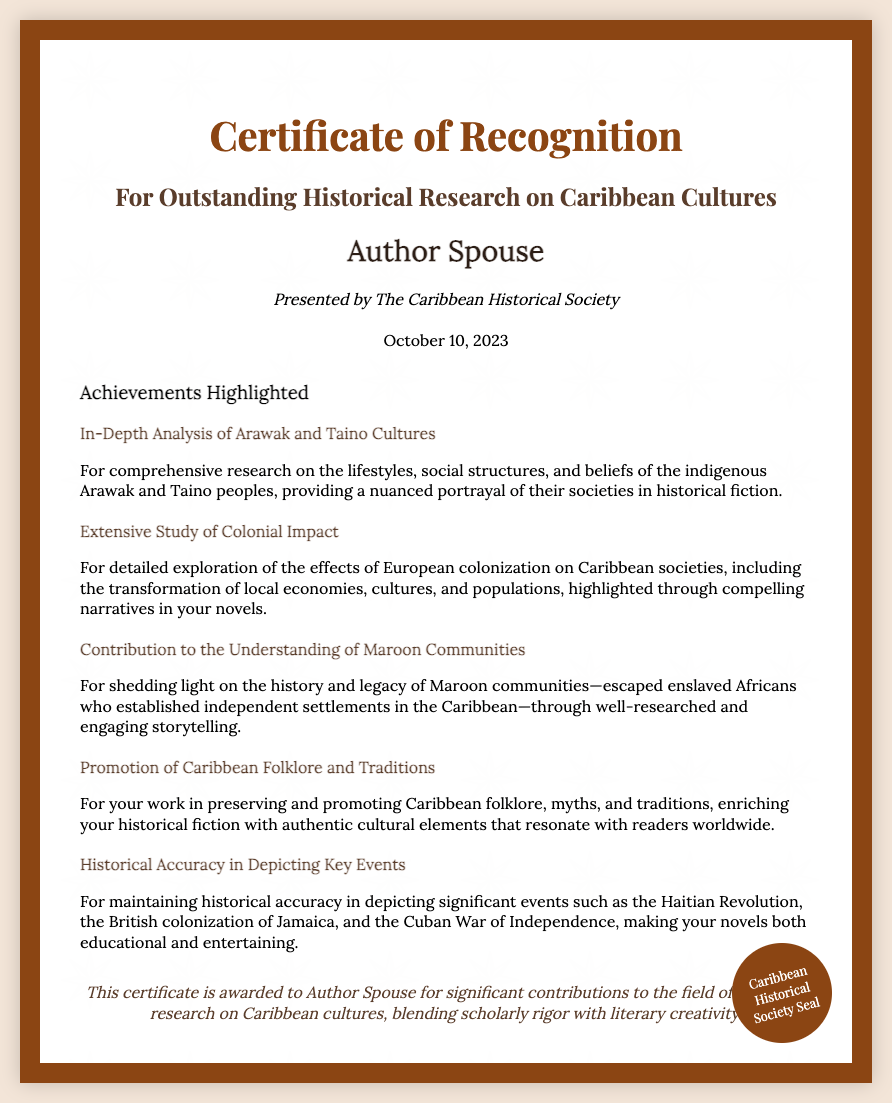What is the title of the certificate? The title of the certificate is prominently displayed at the top of the document.
Answer: Certificate of Recognition Who presented the certificate? The presenter of the certificate is named in a specific section of the document.
Answer: The Caribbean Historical Society What date was the certificate awarded? The date of the award is clearly indicated on the document.
Answer: October 10, 2023 What is one of the achievements highlighted in the certificate? Achievements are listed in a dedicated section, showcasing specific contributions.
Answer: In-Depth Analysis of Arawak and Taino Cultures How many achievements are highlighted in total? The document lists a specific number of achievements, each detailing a significant contribution.
Answer: Five What is emphasized about maintaining historical accuracy? The document mentions specific historical events where accuracy is crucial to the author's work.
Answer: Haitian Revolution What genre do the recipient's works belong to? The type of written works is implied through the context of the certificate.
Answer: Historical fiction What is the color of the certificate's border? The border color is described in the document's styling description.
Answer: Brown 